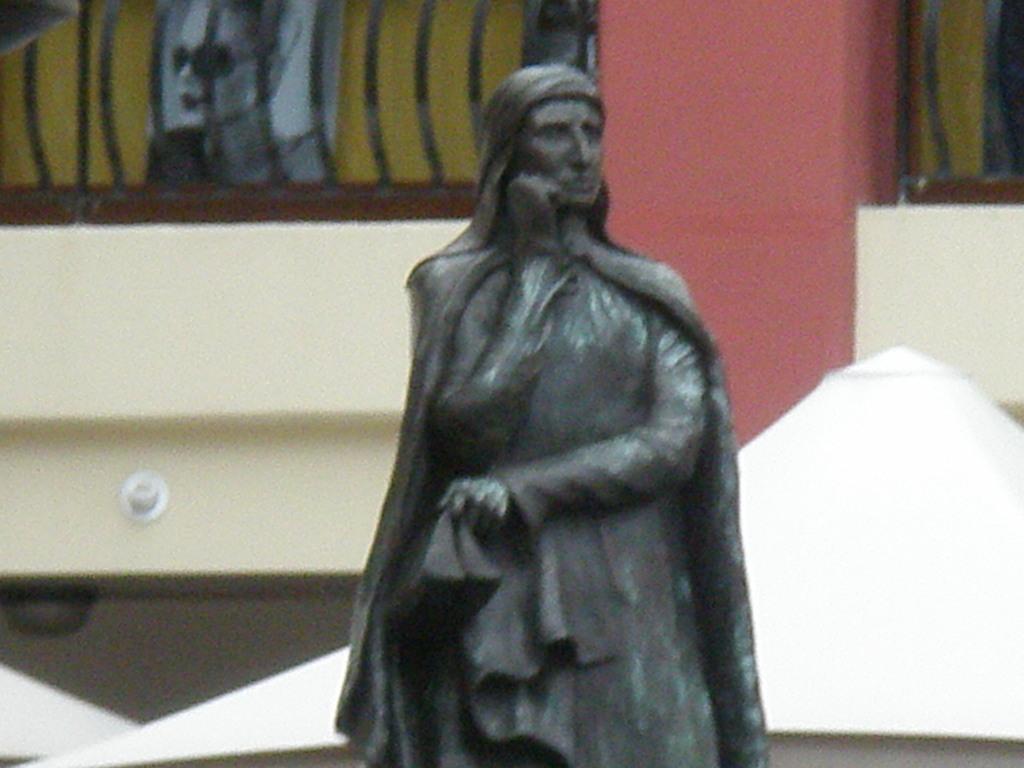Please provide a concise description of this image. In the middle of this image, there is a statue of a woman. In the background, there is a red color pillar, a fence, a wall, a poster and there are other objects. 